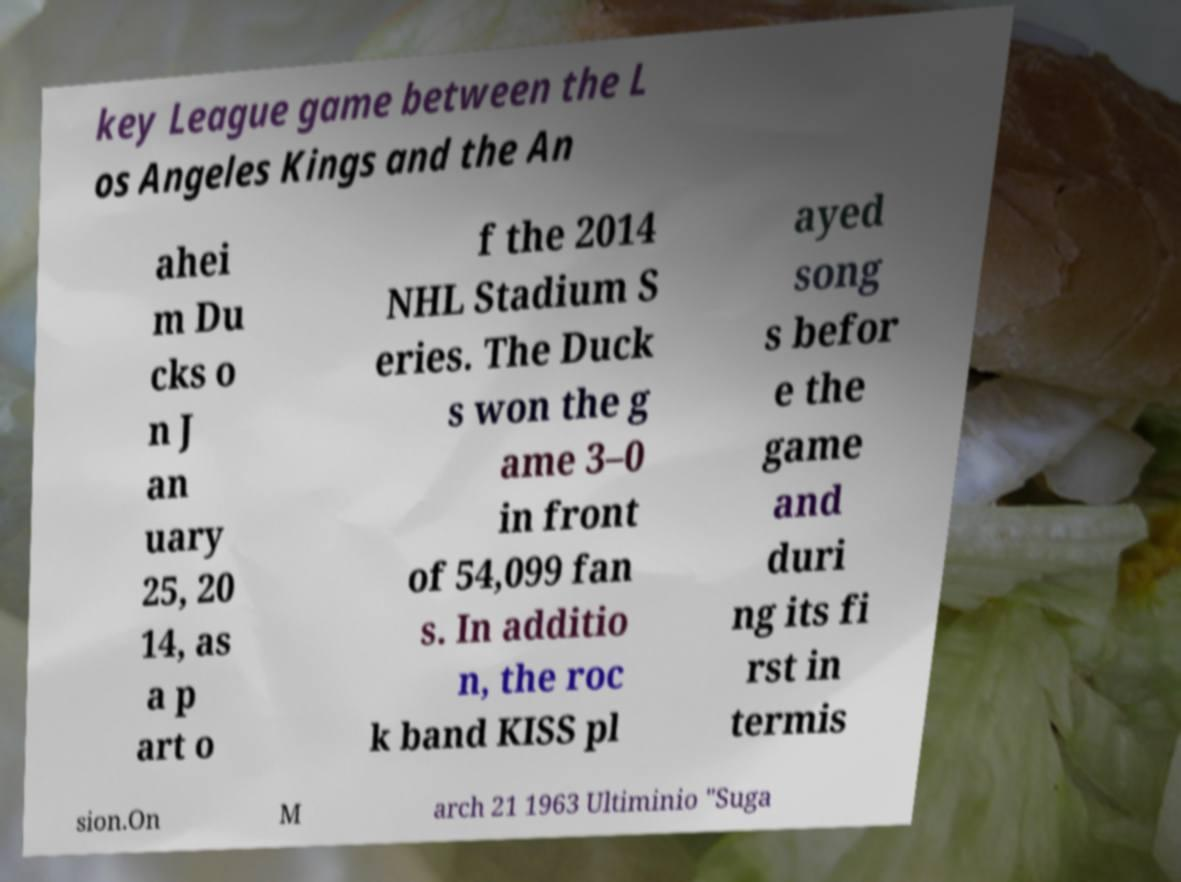For documentation purposes, I need the text within this image transcribed. Could you provide that? key League game between the L os Angeles Kings and the An ahei m Du cks o n J an uary 25, 20 14, as a p art o f the 2014 NHL Stadium S eries. The Duck s won the g ame 3–0 in front of 54,099 fan s. In additio n, the roc k band KISS pl ayed song s befor e the game and duri ng its fi rst in termis sion.On M arch 21 1963 Ultiminio "Suga 